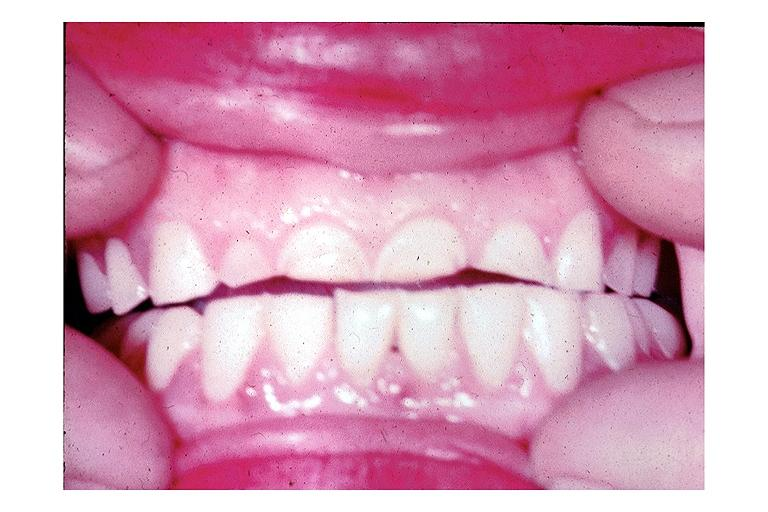s polycystic disease present?
Answer the question using a single word or phrase. No 